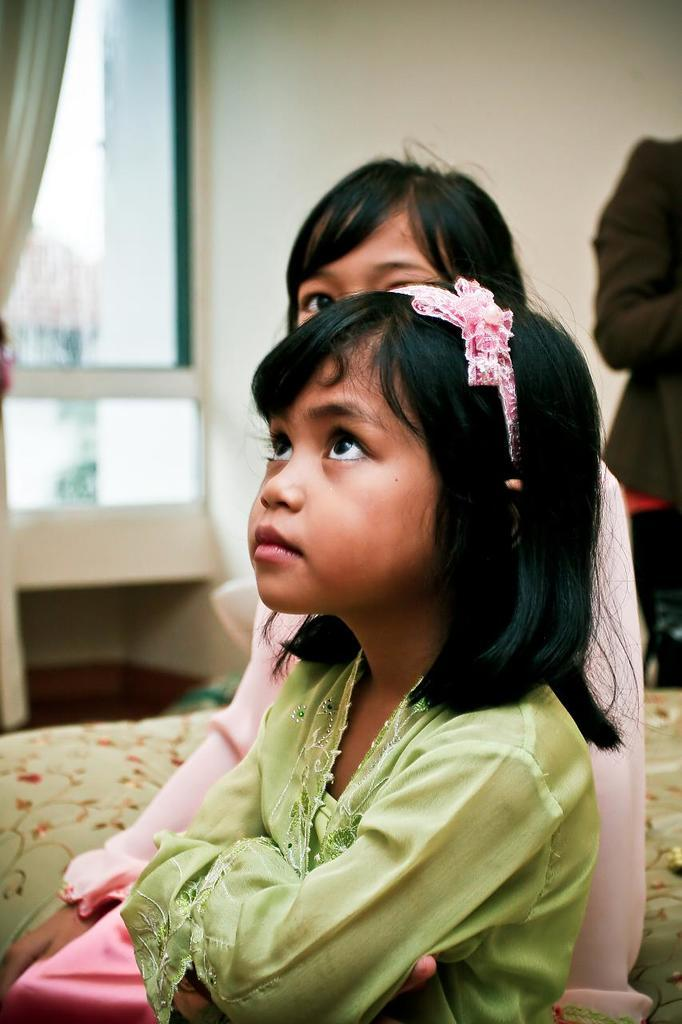How many people are present in the image? There are two girls in the image. Can you describe the background of the image? There is a person and a window visible in the background of the image. What type of bone is being held by the girl on the left in the image? There is no bone visible in the image; the girls are not holding any bones. 